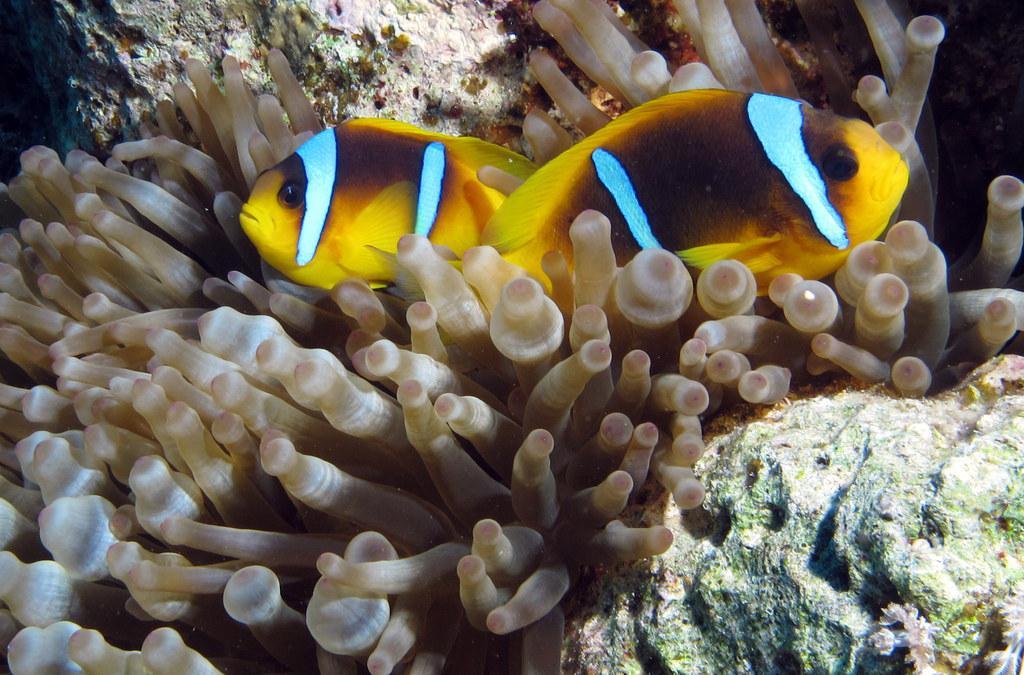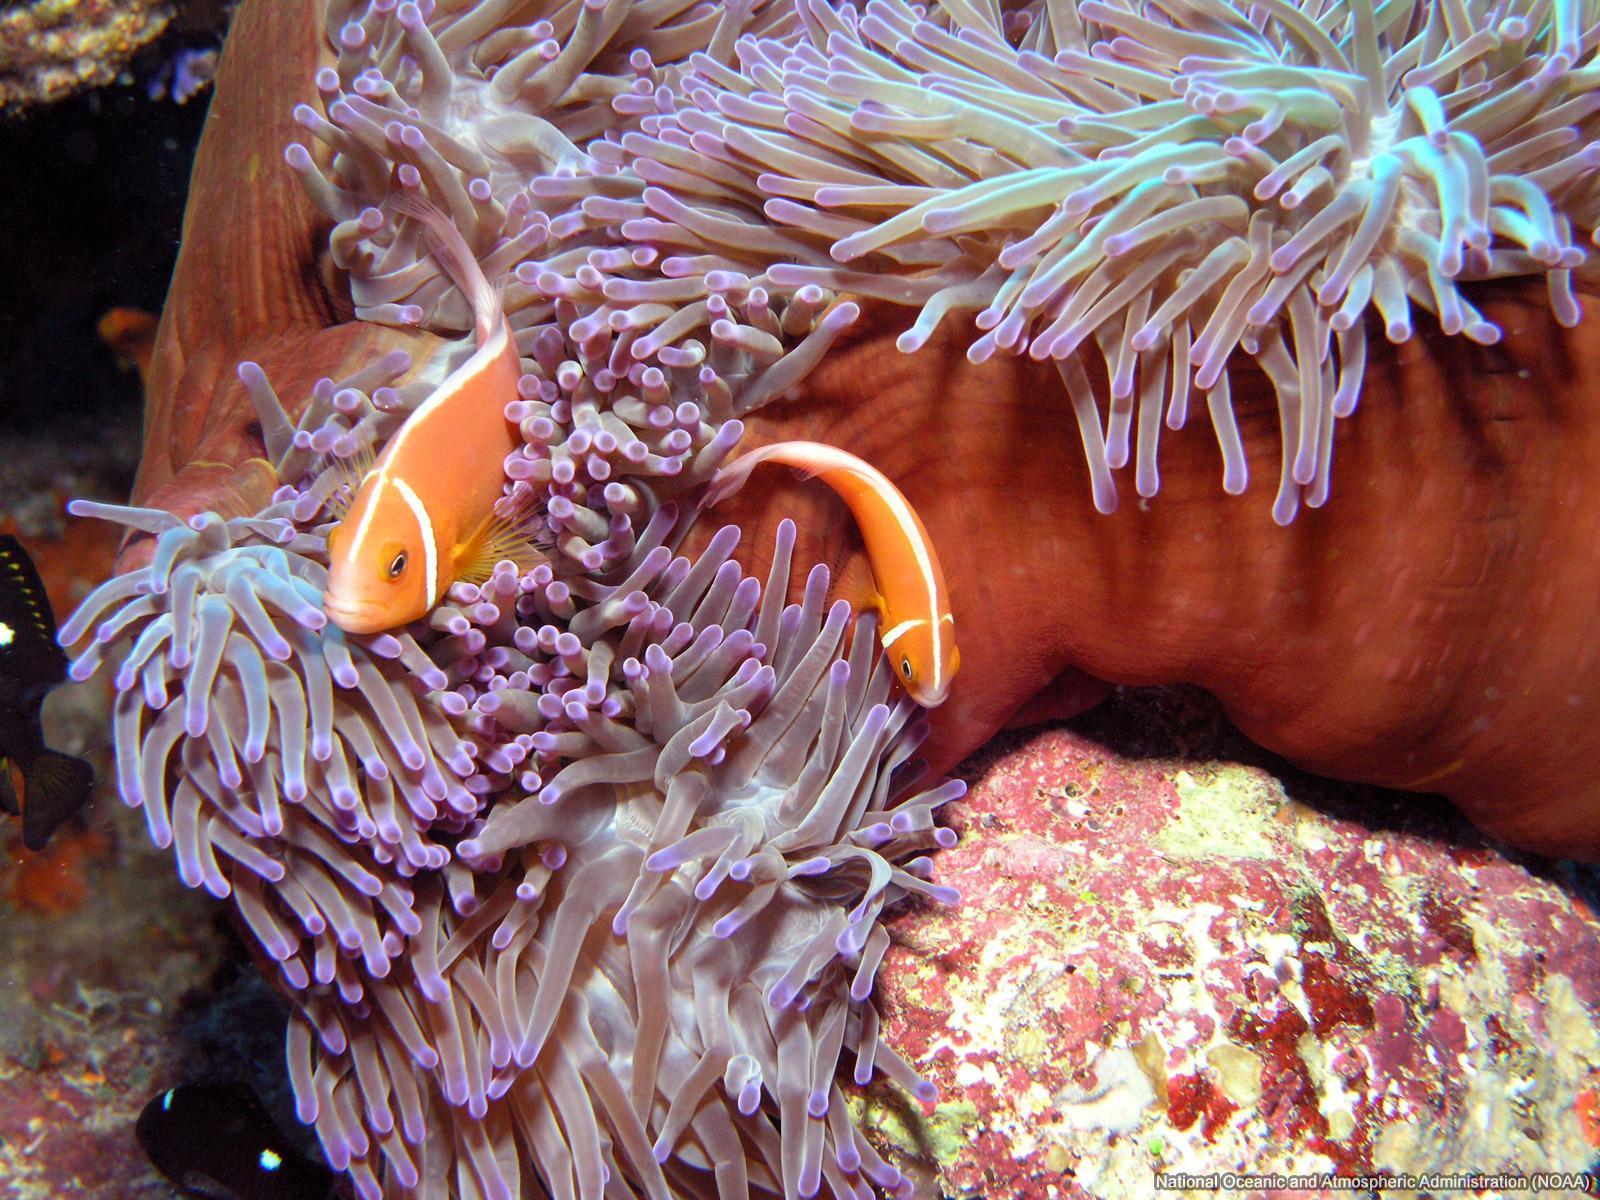The first image is the image on the left, the second image is the image on the right. Given the left and right images, does the statement "At least one colorful fish is near the purple-tipped slender tendrils of an anemone in one image." hold true? Answer yes or no. Yes. 